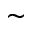Convert formula to latex. <formula><loc_0><loc_0><loc_500><loc_500>\sim</formula> 